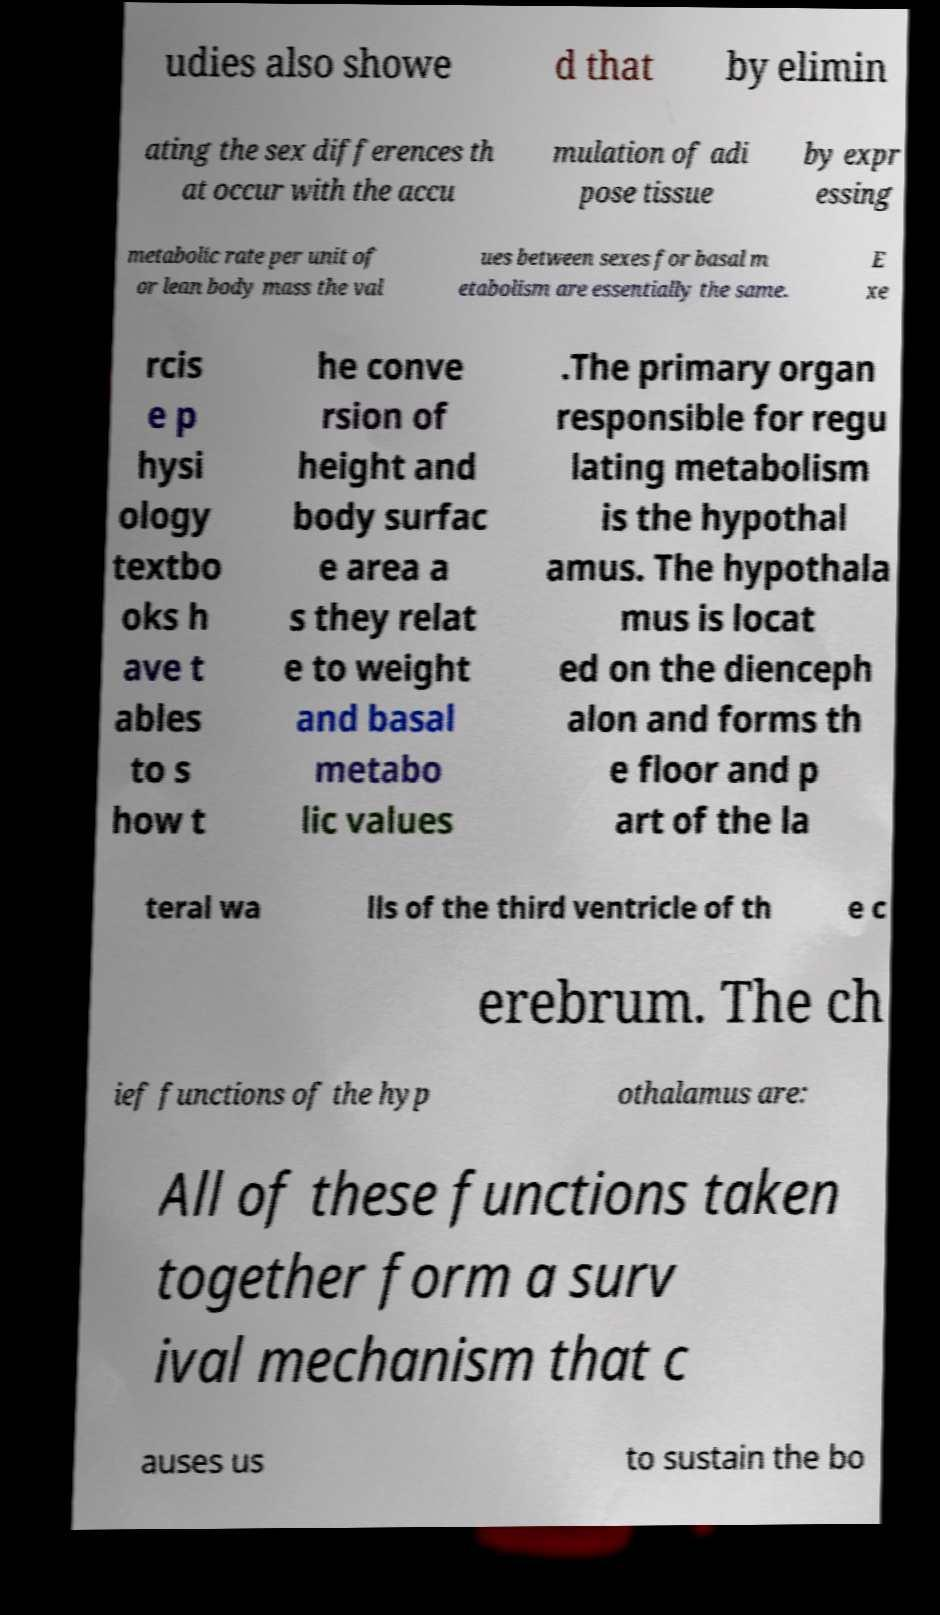Please read and relay the text visible in this image. What does it say? udies also showe d that by elimin ating the sex differences th at occur with the accu mulation of adi pose tissue by expr essing metabolic rate per unit of or lean body mass the val ues between sexes for basal m etabolism are essentially the same. E xe rcis e p hysi ology textbo oks h ave t ables to s how t he conve rsion of height and body surfac e area a s they relat e to weight and basal metabo lic values .The primary organ responsible for regu lating metabolism is the hypothal amus. The hypothala mus is locat ed on the dienceph alon and forms th e floor and p art of the la teral wa lls of the third ventricle of th e c erebrum. The ch ief functions of the hyp othalamus are: All of these functions taken together form a surv ival mechanism that c auses us to sustain the bo 